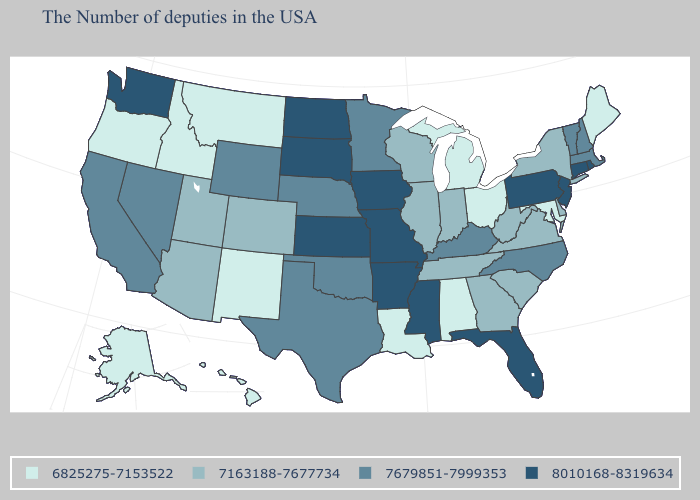Does Arkansas have the highest value in the USA?
Concise answer only. Yes. Name the states that have a value in the range 7679851-7999353?
Answer briefly. Massachusetts, New Hampshire, Vermont, North Carolina, Kentucky, Minnesota, Nebraska, Oklahoma, Texas, Wyoming, Nevada, California. What is the value of Montana?
Be succinct. 6825275-7153522. Is the legend a continuous bar?
Answer briefly. No. Among the states that border Illinois , does Wisconsin have the lowest value?
Quick response, please. Yes. What is the value of Oklahoma?
Keep it brief. 7679851-7999353. Does the first symbol in the legend represent the smallest category?
Keep it brief. Yes. What is the value of New York?
Give a very brief answer. 7163188-7677734. What is the highest value in the USA?
Answer briefly. 8010168-8319634. What is the value of Oregon?
Answer briefly. 6825275-7153522. Name the states that have a value in the range 7679851-7999353?
Keep it brief. Massachusetts, New Hampshire, Vermont, North Carolina, Kentucky, Minnesota, Nebraska, Oklahoma, Texas, Wyoming, Nevada, California. Does Michigan have the highest value in the USA?
Be succinct. No. Does the first symbol in the legend represent the smallest category?
Keep it brief. Yes. Name the states that have a value in the range 7163188-7677734?
Quick response, please. New York, Delaware, Virginia, South Carolina, West Virginia, Georgia, Indiana, Tennessee, Wisconsin, Illinois, Colorado, Utah, Arizona. 